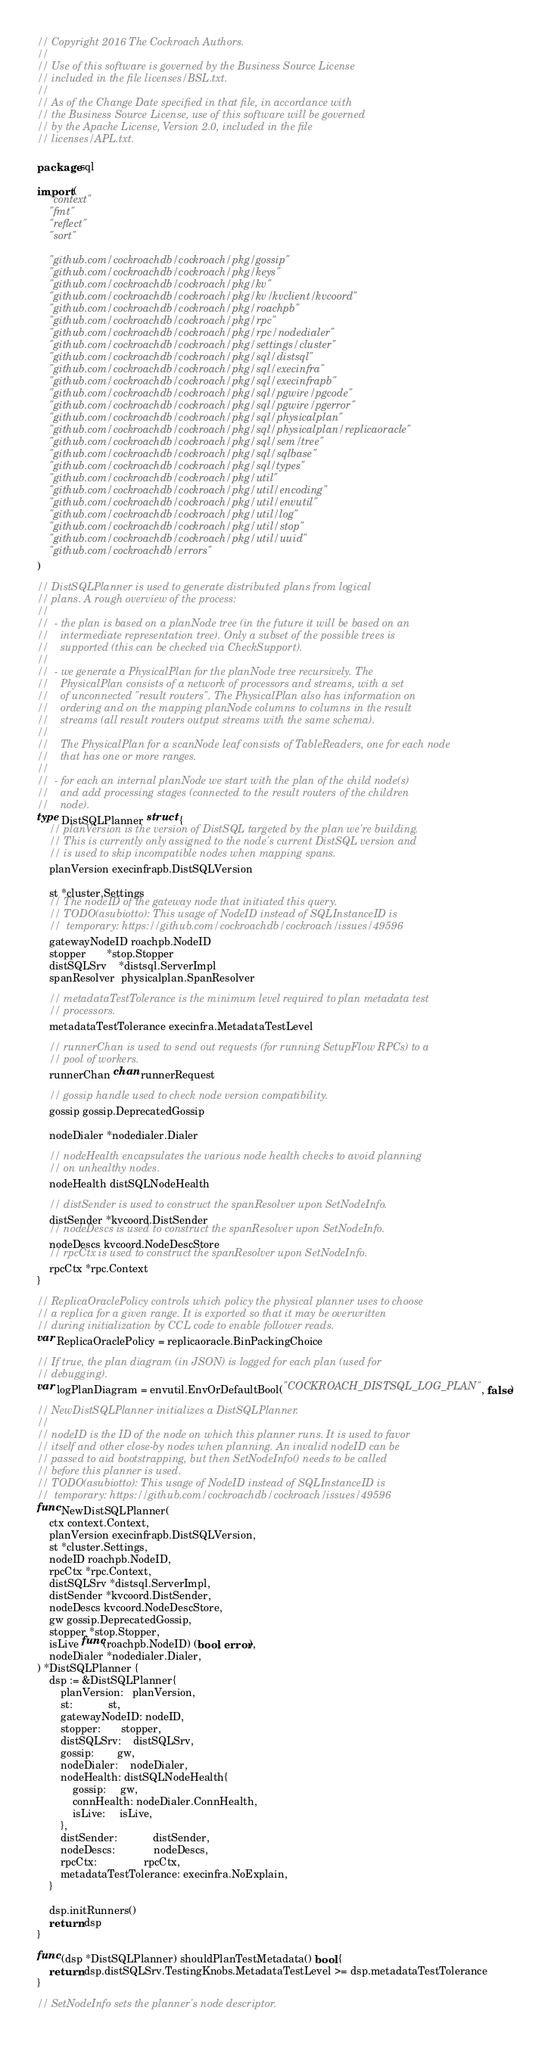<code> <loc_0><loc_0><loc_500><loc_500><_Go_>// Copyright 2016 The Cockroach Authors.
//
// Use of this software is governed by the Business Source License
// included in the file licenses/BSL.txt.
//
// As of the Change Date specified in that file, in accordance with
// the Business Source License, use of this software will be governed
// by the Apache License, Version 2.0, included in the file
// licenses/APL.txt.

package sql

import (
	"context"
	"fmt"
	"reflect"
	"sort"

	"github.com/cockroachdb/cockroach/pkg/gossip"
	"github.com/cockroachdb/cockroach/pkg/keys"
	"github.com/cockroachdb/cockroach/pkg/kv"
	"github.com/cockroachdb/cockroach/pkg/kv/kvclient/kvcoord"
	"github.com/cockroachdb/cockroach/pkg/roachpb"
	"github.com/cockroachdb/cockroach/pkg/rpc"
	"github.com/cockroachdb/cockroach/pkg/rpc/nodedialer"
	"github.com/cockroachdb/cockroach/pkg/settings/cluster"
	"github.com/cockroachdb/cockroach/pkg/sql/distsql"
	"github.com/cockroachdb/cockroach/pkg/sql/execinfra"
	"github.com/cockroachdb/cockroach/pkg/sql/execinfrapb"
	"github.com/cockroachdb/cockroach/pkg/sql/pgwire/pgcode"
	"github.com/cockroachdb/cockroach/pkg/sql/pgwire/pgerror"
	"github.com/cockroachdb/cockroach/pkg/sql/physicalplan"
	"github.com/cockroachdb/cockroach/pkg/sql/physicalplan/replicaoracle"
	"github.com/cockroachdb/cockroach/pkg/sql/sem/tree"
	"github.com/cockroachdb/cockroach/pkg/sql/sqlbase"
	"github.com/cockroachdb/cockroach/pkg/sql/types"
	"github.com/cockroachdb/cockroach/pkg/util"
	"github.com/cockroachdb/cockroach/pkg/util/encoding"
	"github.com/cockroachdb/cockroach/pkg/util/envutil"
	"github.com/cockroachdb/cockroach/pkg/util/log"
	"github.com/cockroachdb/cockroach/pkg/util/stop"
	"github.com/cockroachdb/cockroach/pkg/util/uuid"
	"github.com/cockroachdb/errors"
)

// DistSQLPlanner is used to generate distributed plans from logical
// plans. A rough overview of the process:
//
//  - the plan is based on a planNode tree (in the future it will be based on an
//    intermediate representation tree). Only a subset of the possible trees is
//    supported (this can be checked via CheckSupport).
//
//  - we generate a PhysicalPlan for the planNode tree recursively. The
//    PhysicalPlan consists of a network of processors and streams, with a set
//    of unconnected "result routers". The PhysicalPlan also has information on
//    ordering and on the mapping planNode columns to columns in the result
//    streams (all result routers output streams with the same schema).
//
//    The PhysicalPlan for a scanNode leaf consists of TableReaders, one for each node
//    that has one or more ranges.
//
//  - for each an internal planNode we start with the plan of the child node(s)
//    and add processing stages (connected to the result routers of the children
//    node).
type DistSQLPlanner struct {
	// planVersion is the version of DistSQL targeted by the plan we're building.
	// This is currently only assigned to the node's current DistSQL version and
	// is used to skip incompatible nodes when mapping spans.
	planVersion execinfrapb.DistSQLVersion

	st *cluster.Settings
	// The nodeID of the gateway node that initiated this query.
	// TODO(asubiotto): This usage of NodeID instead of SQLInstanceID is
	//  temporary: https://github.com/cockroachdb/cockroach/issues/49596
	gatewayNodeID roachpb.NodeID
	stopper       *stop.Stopper
	distSQLSrv    *distsql.ServerImpl
	spanResolver  physicalplan.SpanResolver

	// metadataTestTolerance is the minimum level required to plan metadata test
	// processors.
	metadataTestTolerance execinfra.MetadataTestLevel

	// runnerChan is used to send out requests (for running SetupFlow RPCs) to a
	// pool of workers.
	runnerChan chan runnerRequest

	// gossip handle used to check node version compatibility.
	gossip gossip.DeprecatedGossip

	nodeDialer *nodedialer.Dialer

	// nodeHealth encapsulates the various node health checks to avoid planning
	// on unhealthy nodes.
	nodeHealth distSQLNodeHealth

	// distSender is used to construct the spanResolver upon SetNodeInfo.
	distSender *kvcoord.DistSender
	// nodeDescs is used to construct the spanResolver upon SetNodeInfo.
	nodeDescs kvcoord.NodeDescStore
	// rpcCtx is used to construct the spanResolver upon SetNodeInfo.
	rpcCtx *rpc.Context
}

// ReplicaOraclePolicy controls which policy the physical planner uses to choose
// a replica for a given range. It is exported so that it may be overwritten
// during initialization by CCL code to enable follower reads.
var ReplicaOraclePolicy = replicaoracle.BinPackingChoice

// If true, the plan diagram (in JSON) is logged for each plan (used for
// debugging).
var logPlanDiagram = envutil.EnvOrDefaultBool("COCKROACH_DISTSQL_LOG_PLAN", false)

// NewDistSQLPlanner initializes a DistSQLPlanner.
//
// nodeID is the ID of the node on which this planner runs. It is used to favor
// itself and other close-by nodes when planning. An invalid nodeID can be
// passed to aid bootstrapping, but then SetNodeInfo() needs to be called
// before this planner is used.
// TODO(asubiotto): This usage of NodeID instead of SQLInstanceID is
//  temporary: https://github.com/cockroachdb/cockroach/issues/49596
func NewDistSQLPlanner(
	ctx context.Context,
	planVersion execinfrapb.DistSQLVersion,
	st *cluster.Settings,
	nodeID roachpb.NodeID,
	rpcCtx *rpc.Context,
	distSQLSrv *distsql.ServerImpl,
	distSender *kvcoord.DistSender,
	nodeDescs kvcoord.NodeDescStore,
	gw gossip.DeprecatedGossip,
	stopper *stop.Stopper,
	isLive func(roachpb.NodeID) (bool, error),
	nodeDialer *nodedialer.Dialer,
) *DistSQLPlanner {
	dsp := &DistSQLPlanner{
		planVersion:   planVersion,
		st:            st,
		gatewayNodeID: nodeID,
		stopper:       stopper,
		distSQLSrv:    distSQLSrv,
		gossip:        gw,
		nodeDialer:    nodeDialer,
		nodeHealth: distSQLNodeHealth{
			gossip:     gw,
			connHealth: nodeDialer.ConnHealth,
			isLive:     isLive,
		},
		distSender:            distSender,
		nodeDescs:             nodeDescs,
		rpcCtx:                rpcCtx,
		metadataTestTolerance: execinfra.NoExplain,
	}

	dsp.initRunners()
	return dsp
}

func (dsp *DistSQLPlanner) shouldPlanTestMetadata() bool {
	return dsp.distSQLSrv.TestingKnobs.MetadataTestLevel >= dsp.metadataTestTolerance
}

// SetNodeInfo sets the planner's node descriptor.</code> 